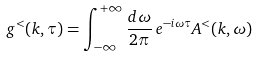Convert formula to latex. <formula><loc_0><loc_0><loc_500><loc_500>g ^ { < } ( k , \tau ) = \int _ { - \infty } ^ { + \infty } \frac { { d } \omega } { 2 \pi } \, e ^ { - { i } \omega \tau } A ^ { < } ( k , \omega )</formula> 